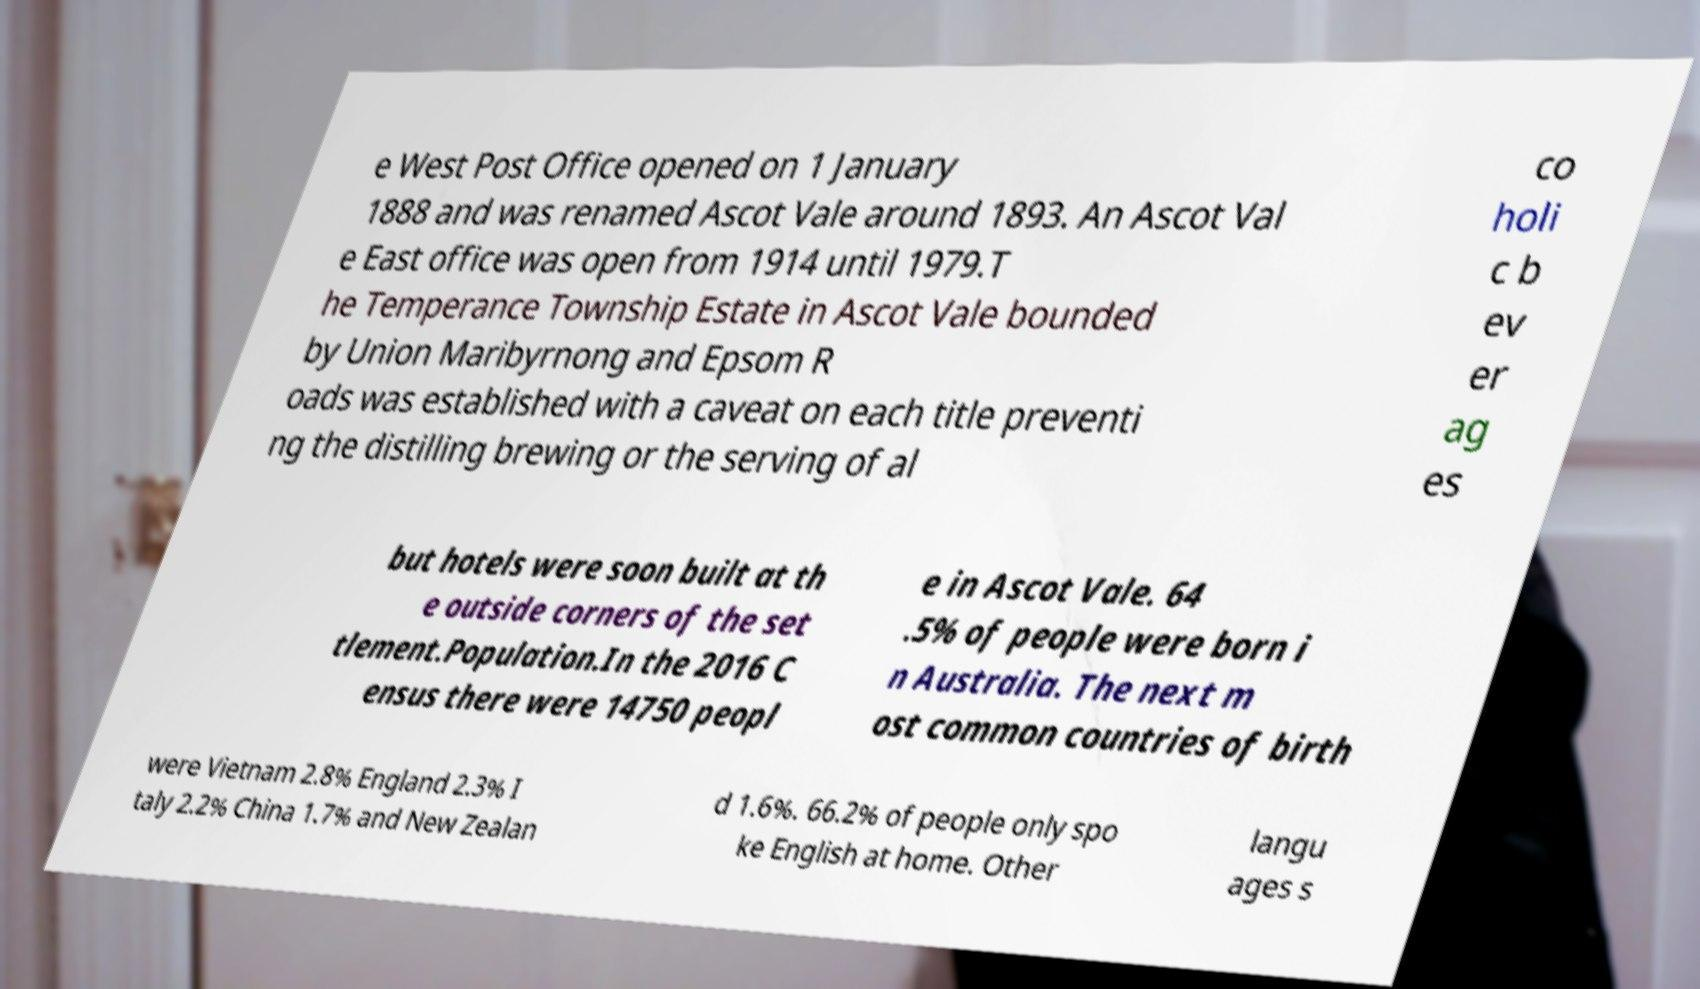Please identify and transcribe the text found in this image. e West Post Office opened on 1 January 1888 and was renamed Ascot Vale around 1893. An Ascot Val e East office was open from 1914 until 1979.T he Temperance Township Estate in Ascot Vale bounded by Union Maribyrnong and Epsom R oads was established with a caveat on each title preventi ng the distilling brewing or the serving of al co holi c b ev er ag es but hotels were soon built at th e outside corners of the set tlement.Population.In the 2016 C ensus there were 14750 peopl e in Ascot Vale. 64 .5% of people were born i n Australia. The next m ost common countries of birth were Vietnam 2.8% England 2.3% I taly 2.2% China 1.7% and New Zealan d 1.6%. 66.2% of people only spo ke English at home. Other langu ages s 